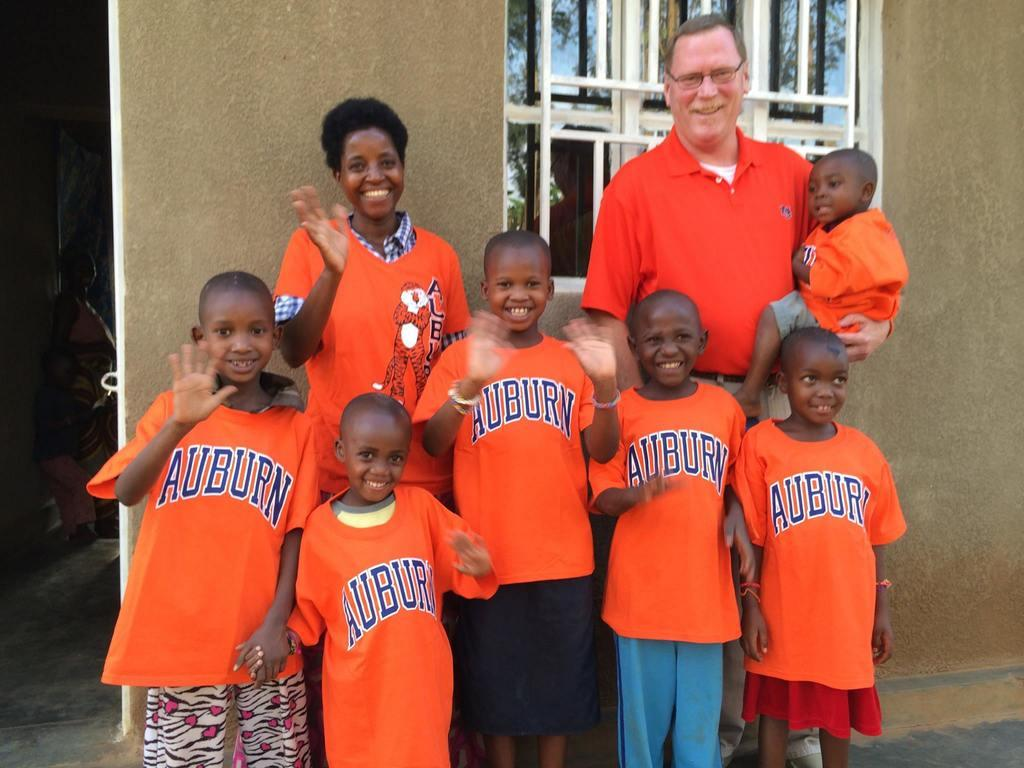Provide a one-sentence caption for the provided image. A group of children are wearing Auburn shirts and waving to the camera. 